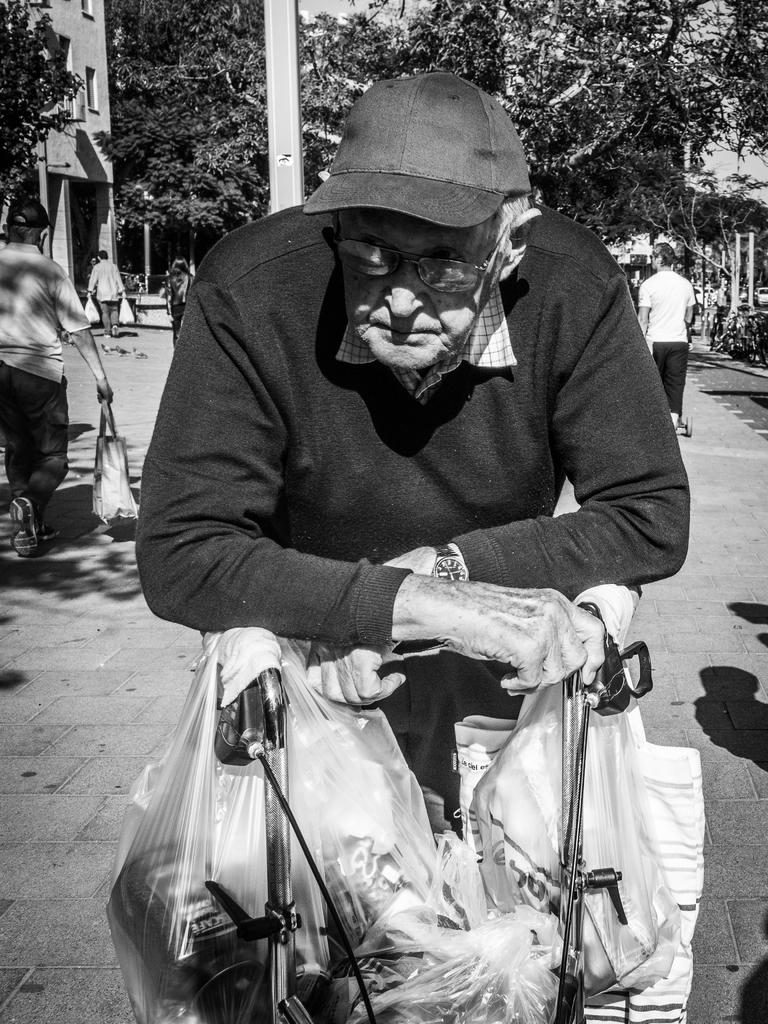What is the main subject in the foreground of the image? There is an old man in the foreground of the image. What is the old man doing in the image? The old man is carrying something. Can you describe the old man's attire? The old man is wearing a cap. What architectural feature can be seen in the image? There is a pillar visible in the image. What is happening in the background of the image? There are people walking in the background of the image. What type of vegetation is present in the image? There are trees present in the image. What type of pie is being served at the meal in the image? There is no meal or pie present in the image; it features an old man carrying something and people walking in the background. 